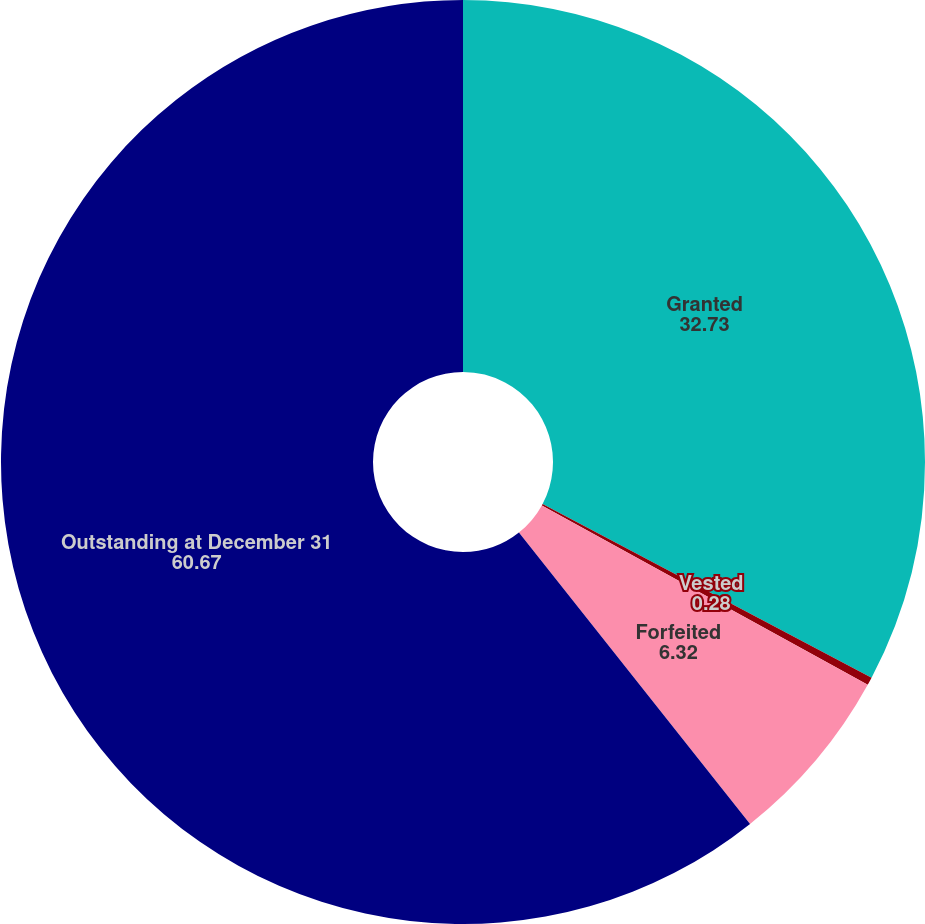<chart> <loc_0><loc_0><loc_500><loc_500><pie_chart><fcel>Granted<fcel>Vested<fcel>Forfeited<fcel>Outstanding at December 31<nl><fcel>32.73%<fcel>0.28%<fcel>6.32%<fcel>60.67%<nl></chart> 